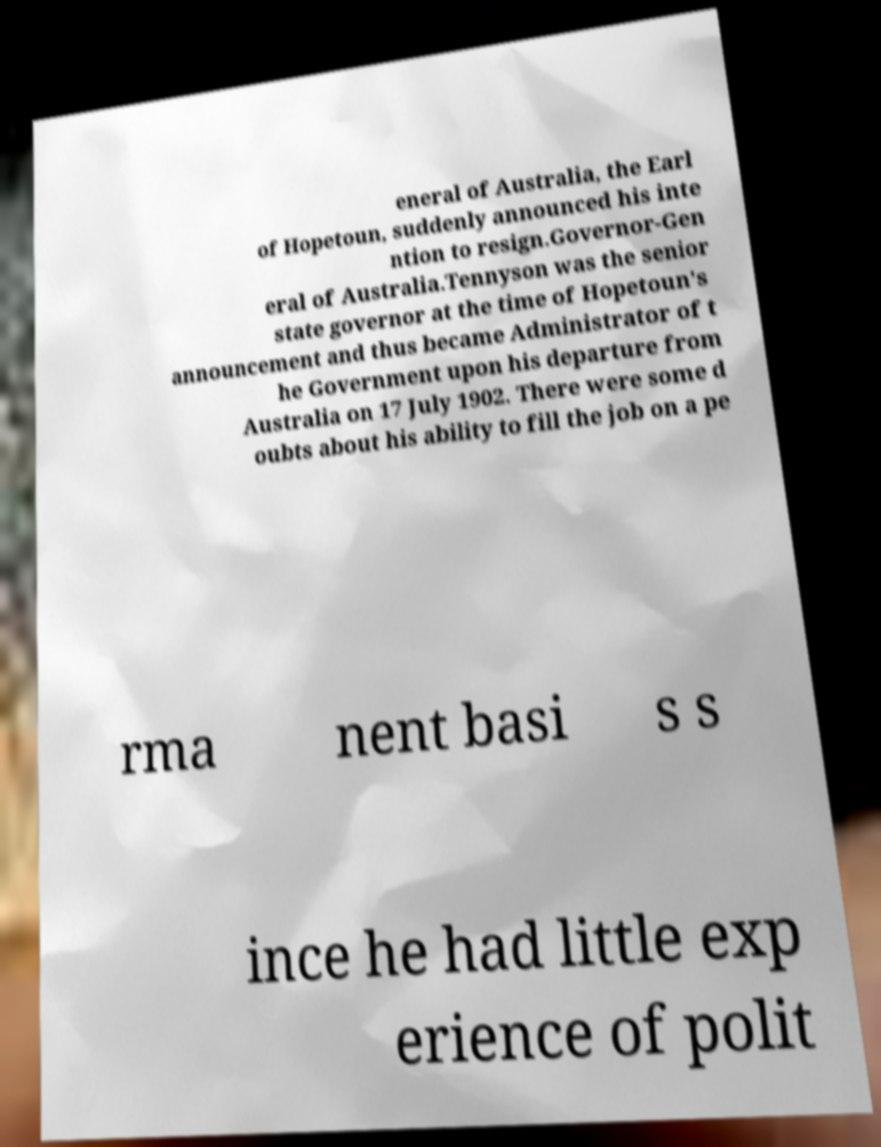Please identify and transcribe the text found in this image. eneral of Australia, the Earl of Hopetoun, suddenly announced his inte ntion to resign.Governor-Gen eral of Australia.Tennyson was the senior state governor at the time of Hopetoun's announcement and thus became Administrator of t he Government upon his departure from Australia on 17 July 1902. There were some d oubts about his ability to fill the job on a pe rma nent basi s s ince he had little exp erience of polit 